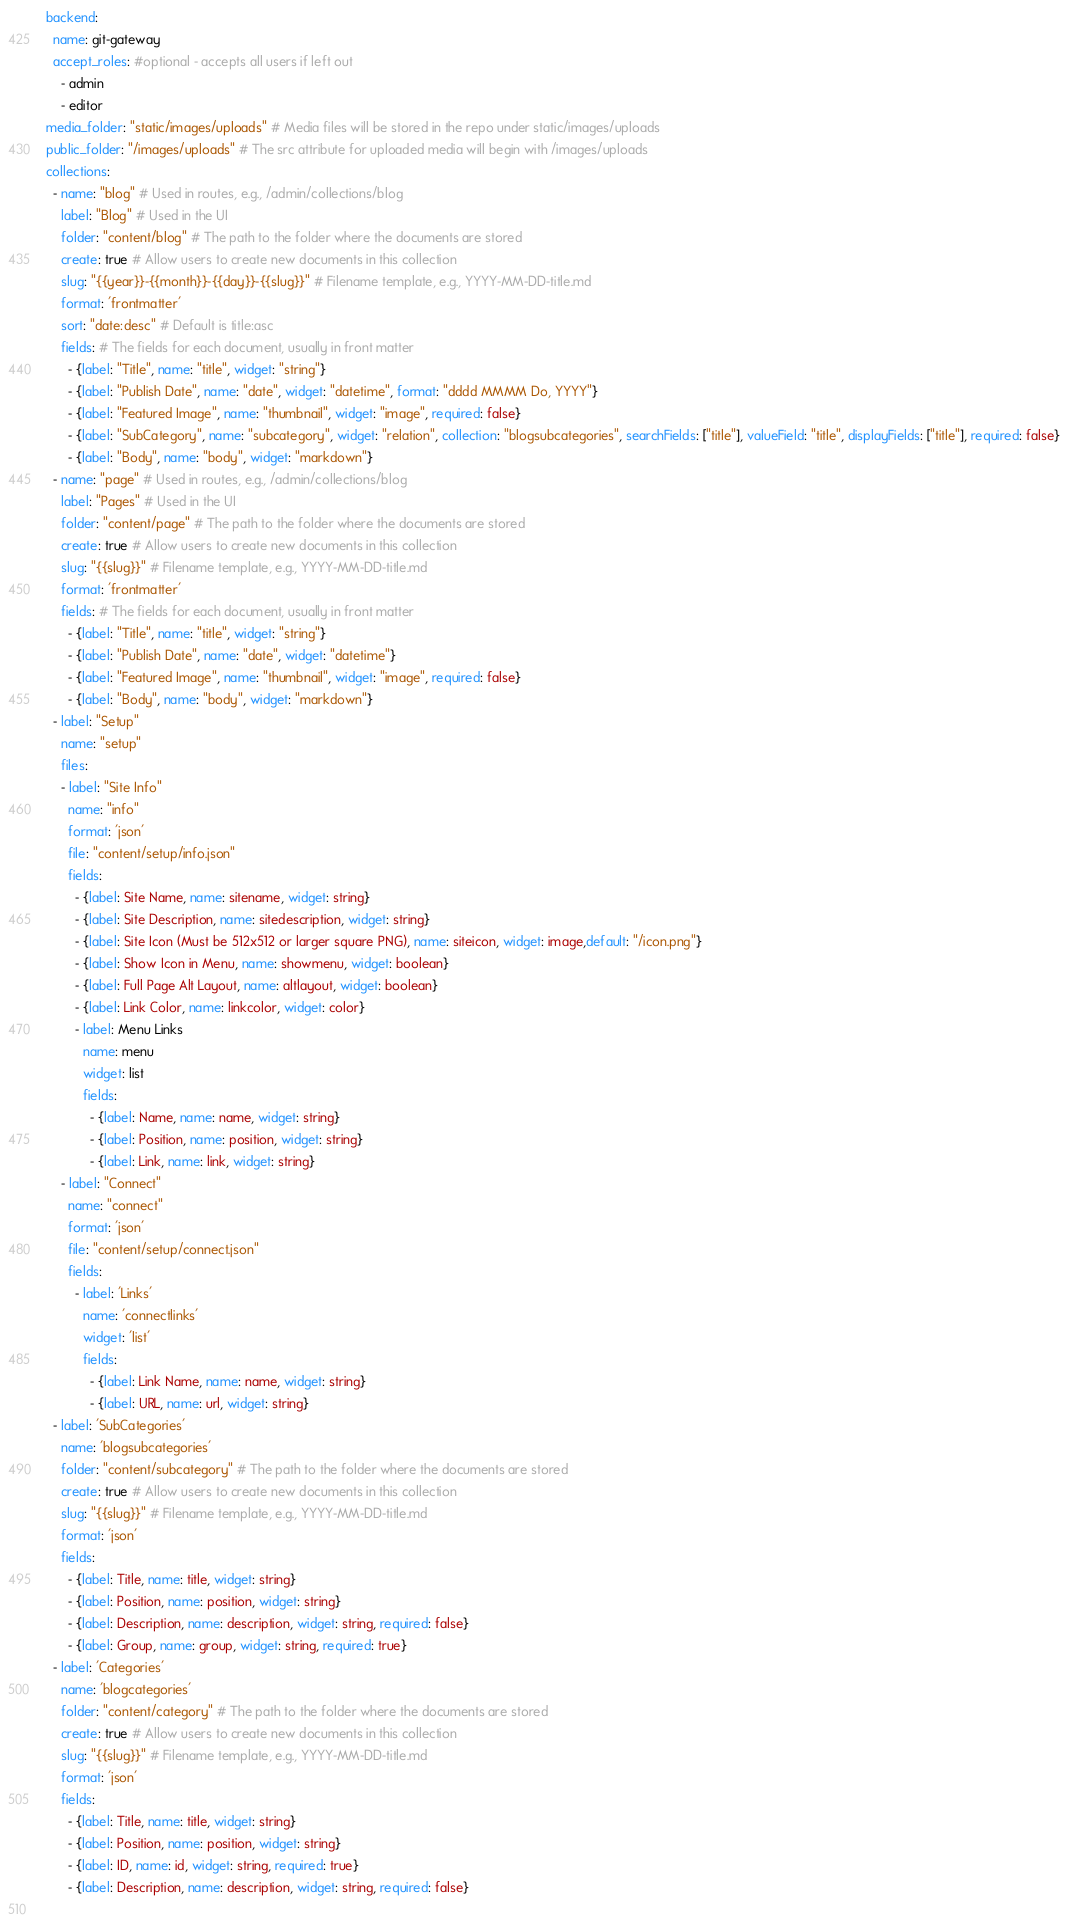Convert code to text. <code><loc_0><loc_0><loc_500><loc_500><_YAML_>backend:
  name: git-gateway
  accept_roles: #optional - accepts all users if left out
    - admin
    - editor
media_folder: "static/images/uploads" # Media files will be stored in the repo under static/images/uploads
public_folder: "/images/uploads" # The src attribute for uploaded media will begin with /images/uploads
collections:
  - name: "blog" # Used in routes, e.g., /admin/collections/blog
    label: "Blog" # Used in the UI
    folder: "content/blog" # The path to the folder where the documents are stored
    create: true # Allow users to create new documents in this collection
    slug: "{{year}}-{{month}}-{{day}}-{{slug}}" # Filename template, e.g., YYYY-MM-DD-title.md
    format: 'frontmatter'
    sort: "date:desc" # Default is title:asc
    fields: # The fields for each document, usually in front matter
      - {label: "Title", name: "title", widget: "string"}
      - {label: "Publish Date", name: "date", widget: "datetime", format: "dddd MMMM Do, YYYY"}
      - {label: "Featured Image", name: "thumbnail", widget: "image", required: false}
      - {label: "SubCategory", name: "subcategory", widget: "relation", collection: "blogsubcategories", searchFields: ["title"], valueField: "title", displayFields: ["title"], required: false}
      - {label: "Body", name: "body", widget: "markdown"}
  - name: "page" # Used in routes, e.g., /admin/collections/blog
    label: "Pages" # Used in the UI
    folder: "content/page" # The path to the folder where the documents are stored
    create: true # Allow users to create new documents in this collection
    slug: "{{slug}}" # Filename template, e.g., YYYY-MM-DD-title.md
    format: 'frontmatter'
    fields: # The fields for each document, usually in front matter
      - {label: "Title", name: "title", widget: "string"}
      - {label: "Publish Date", name: "date", widget: "datetime"}
      - {label: "Featured Image", name: "thumbnail", widget: "image", required: false}
      - {label: "Body", name: "body", widget: "markdown"}
  - label: "Setup"
    name: "setup"
    files:
    - label: "Site Info"
      name: "info"
      format: 'json'
      file: "content/setup/info.json"
      fields:
        - {label: Site Name, name: sitename, widget: string}
        - {label: Site Description, name: sitedescription, widget: string}
        - {label: Site Icon (Must be 512x512 or larger square PNG), name: siteicon, widget: image,default: "/icon.png"}
        - {label: Show Icon in Menu, name: showmenu, widget: boolean}
        - {label: Full Page Alt Layout, name: altlayout, widget: boolean}
        - {label: Link Color, name: linkcolor, widget: color}
        - label: Menu Links
          name: menu
          widget: list
          fields:
            - {label: Name, name: name, widget: string}
            - {label: Position, name: position, widget: string}
            - {label: Link, name: link, widget: string}
    - label: "Connect"
      name: "connect"
      format: 'json'
      file: "content/setup/connect.json"
      fields:
        - label: 'Links'
          name: 'connectlinks'
          widget: 'list'
          fields:
            - {label: Link Name, name: name, widget: string}
            - {label: URL, name: url, widget: string}
  - label: 'SubCategories'
    name: 'blogsubcategories'
    folder: "content/subcategory" # The path to the folder where the documents are stored
    create: true # Allow users to create new documents in this collection
    slug: "{{slug}}" # Filename template, e.g., YYYY-MM-DD-title.md
    format: 'json'
    fields:
      - {label: Title, name: title, widget: string}
      - {label: Position, name: position, widget: string}
      - {label: Description, name: description, widget: string, required: false}
      - {label: Group, name: group, widget: string, required: true}
  - label: 'Categories'
    name: 'blogcategories'
    folder: "content/category" # The path to the folder where the documents are stored
    create: true # Allow users to create new documents in this collection
    slug: "{{slug}}" # Filename template, e.g., YYYY-MM-DD-title.md
    format: 'json'
    fields:
      - {label: Title, name: title, widget: string}
      - {label: Position, name: position, widget: string}
      - {label: ID, name: id, widget: string, required: true}
      - {label: Description, name: description, widget: string, required: false}
 </code> 